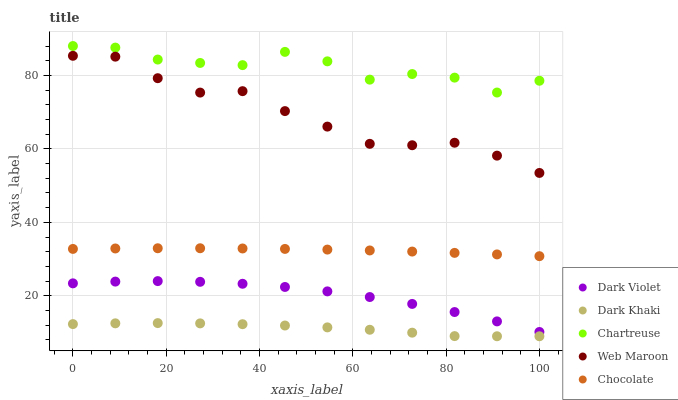Does Dark Khaki have the minimum area under the curve?
Answer yes or no. Yes. Does Chartreuse have the maximum area under the curve?
Answer yes or no. Yes. Does Web Maroon have the minimum area under the curve?
Answer yes or no. No. Does Web Maroon have the maximum area under the curve?
Answer yes or no. No. Is Chocolate the smoothest?
Answer yes or no. Yes. Is Chartreuse the roughest?
Answer yes or no. Yes. Is Web Maroon the smoothest?
Answer yes or no. No. Is Web Maroon the roughest?
Answer yes or no. No. Does Dark Khaki have the lowest value?
Answer yes or no. Yes. Does Web Maroon have the lowest value?
Answer yes or no. No. Does Chartreuse have the highest value?
Answer yes or no. Yes. Does Web Maroon have the highest value?
Answer yes or no. No. Is Dark Violet less than Chartreuse?
Answer yes or no. Yes. Is Web Maroon greater than Chocolate?
Answer yes or no. Yes. Does Dark Violet intersect Chartreuse?
Answer yes or no. No. 